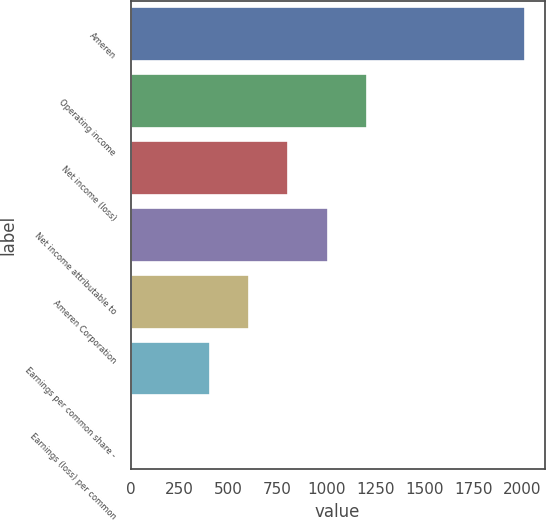Convert chart to OTSL. <chart><loc_0><loc_0><loc_500><loc_500><bar_chart><fcel>Ameren<fcel>Operating income<fcel>Net income (loss)<fcel>Net income attributable to<fcel>Ameren Corporation<fcel>Earnings per common share -<fcel>Earnings (loss) per common<nl><fcel>2013<fcel>1207.95<fcel>805.43<fcel>1006.69<fcel>604.17<fcel>402.91<fcel>0.39<nl></chart> 